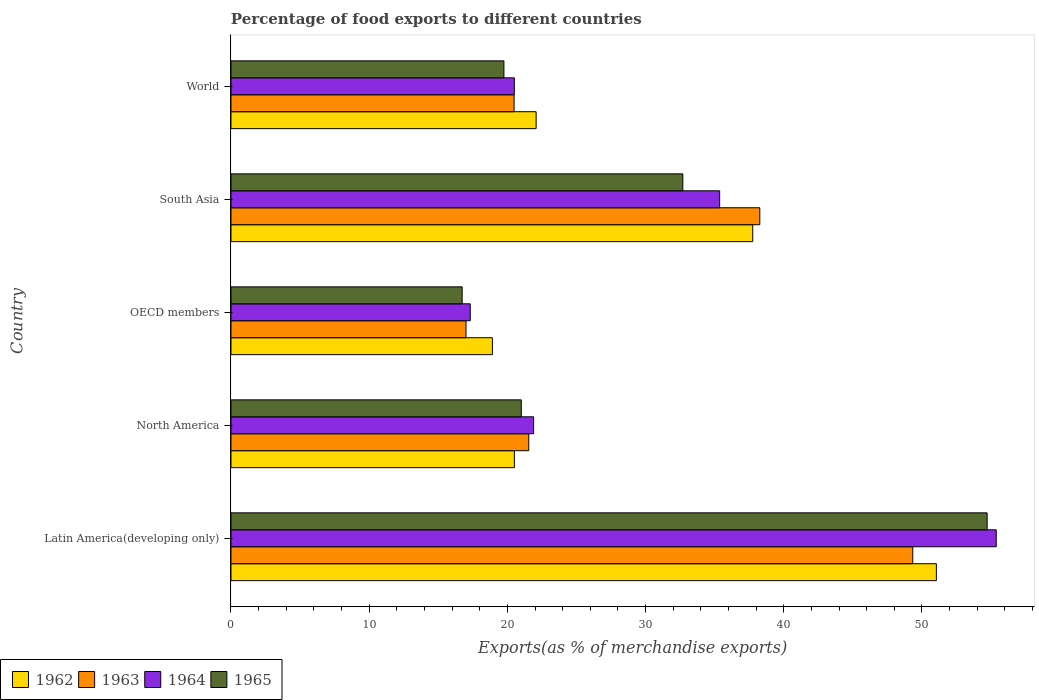How many different coloured bars are there?
Offer a very short reply. 4. How many groups of bars are there?
Make the answer very short. 5. How many bars are there on the 1st tick from the top?
Your answer should be very brief. 4. How many bars are there on the 3rd tick from the bottom?
Your answer should be very brief. 4. What is the label of the 1st group of bars from the top?
Your response must be concise. World. In how many cases, is the number of bars for a given country not equal to the number of legend labels?
Your answer should be very brief. 0. What is the percentage of exports to different countries in 1962 in Latin America(developing only)?
Your answer should be compact. 51.04. Across all countries, what is the maximum percentage of exports to different countries in 1965?
Provide a succinct answer. 54.71. Across all countries, what is the minimum percentage of exports to different countries in 1963?
Offer a terse response. 17.01. In which country was the percentage of exports to different countries in 1965 maximum?
Your answer should be compact. Latin America(developing only). In which country was the percentage of exports to different countries in 1963 minimum?
Give a very brief answer. OECD members. What is the total percentage of exports to different countries in 1965 in the graph?
Offer a very short reply. 144.9. What is the difference between the percentage of exports to different countries in 1965 in South Asia and that in World?
Ensure brevity in your answer.  12.95. What is the difference between the percentage of exports to different countries in 1964 in South Asia and the percentage of exports to different countries in 1965 in OECD members?
Give a very brief answer. 18.63. What is the average percentage of exports to different countries in 1962 per country?
Offer a very short reply. 30.06. What is the difference between the percentage of exports to different countries in 1965 and percentage of exports to different countries in 1964 in Latin America(developing only)?
Keep it short and to the point. -0.66. What is the ratio of the percentage of exports to different countries in 1962 in North America to that in World?
Keep it short and to the point. 0.93. Is the percentage of exports to different countries in 1964 in North America less than that in OECD members?
Ensure brevity in your answer.  No. What is the difference between the highest and the second highest percentage of exports to different countries in 1965?
Your answer should be very brief. 22.02. What is the difference between the highest and the lowest percentage of exports to different countries in 1962?
Provide a succinct answer. 32.12. In how many countries, is the percentage of exports to different countries in 1964 greater than the average percentage of exports to different countries in 1964 taken over all countries?
Offer a very short reply. 2. Is the sum of the percentage of exports to different countries in 1965 in North America and World greater than the maximum percentage of exports to different countries in 1964 across all countries?
Offer a very short reply. No. What does the 1st bar from the top in North America represents?
Offer a very short reply. 1965. Is it the case that in every country, the sum of the percentage of exports to different countries in 1964 and percentage of exports to different countries in 1963 is greater than the percentage of exports to different countries in 1962?
Your answer should be very brief. Yes. How many bars are there?
Provide a succinct answer. 20. Are all the bars in the graph horizontal?
Provide a succinct answer. Yes. What is the difference between two consecutive major ticks on the X-axis?
Your response must be concise. 10. Are the values on the major ticks of X-axis written in scientific E-notation?
Make the answer very short. No. Where does the legend appear in the graph?
Offer a terse response. Bottom left. How are the legend labels stacked?
Keep it short and to the point. Horizontal. What is the title of the graph?
Your answer should be very brief. Percentage of food exports to different countries. What is the label or title of the X-axis?
Give a very brief answer. Exports(as % of merchandise exports). What is the label or title of the Y-axis?
Keep it short and to the point. Country. What is the Exports(as % of merchandise exports) in 1962 in Latin America(developing only)?
Provide a short and direct response. 51.04. What is the Exports(as % of merchandise exports) of 1963 in Latin America(developing only)?
Your answer should be very brief. 49.33. What is the Exports(as % of merchandise exports) of 1964 in Latin America(developing only)?
Ensure brevity in your answer.  55.37. What is the Exports(as % of merchandise exports) of 1965 in Latin America(developing only)?
Your response must be concise. 54.71. What is the Exports(as % of merchandise exports) in 1962 in North America?
Offer a terse response. 20.51. What is the Exports(as % of merchandise exports) in 1963 in North America?
Give a very brief answer. 21.55. What is the Exports(as % of merchandise exports) of 1964 in North America?
Ensure brevity in your answer.  21.9. What is the Exports(as % of merchandise exports) in 1965 in North America?
Give a very brief answer. 21.01. What is the Exports(as % of merchandise exports) of 1962 in OECD members?
Provide a short and direct response. 18.92. What is the Exports(as % of merchandise exports) of 1963 in OECD members?
Your response must be concise. 17.01. What is the Exports(as % of merchandise exports) of 1964 in OECD members?
Your answer should be compact. 17.31. What is the Exports(as % of merchandise exports) in 1965 in OECD members?
Your answer should be very brief. 16.73. What is the Exports(as % of merchandise exports) of 1962 in South Asia?
Offer a very short reply. 37.75. What is the Exports(as % of merchandise exports) of 1963 in South Asia?
Provide a succinct answer. 38.26. What is the Exports(as % of merchandise exports) in 1964 in South Asia?
Your answer should be very brief. 35.36. What is the Exports(as % of merchandise exports) in 1965 in South Asia?
Provide a succinct answer. 32.7. What is the Exports(as % of merchandise exports) of 1962 in World?
Offer a terse response. 22.08. What is the Exports(as % of merchandise exports) in 1963 in World?
Make the answer very short. 20.49. What is the Exports(as % of merchandise exports) in 1964 in World?
Provide a succinct answer. 20.5. What is the Exports(as % of merchandise exports) in 1965 in World?
Your answer should be compact. 19.75. Across all countries, what is the maximum Exports(as % of merchandise exports) of 1962?
Your answer should be very brief. 51.04. Across all countries, what is the maximum Exports(as % of merchandise exports) in 1963?
Provide a short and direct response. 49.33. Across all countries, what is the maximum Exports(as % of merchandise exports) of 1964?
Provide a short and direct response. 55.37. Across all countries, what is the maximum Exports(as % of merchandise exports) in 1965?
Offer a terse response. 54.71. Across all countries, what is the minimum Exports(as % of merchandise exports) in 1962?
Keep it short and to the point. 18.92. Across all countries, what is the minimum Exports(as % of merchandise exports) in 1963?
Offer a terse response. 17.01. Across all countries, what is the minimum Exports(as % of merchandise exports) in 1964?
Give a very brief answer. 17.31. Across all countries, what is the minimum Exports(as % of merchandise exports) in 1965?
Offer a terse response. 16.73. What is the total Exports(as % of merchandise exports) in 1962 in the graph?
Provide a short and direct response. 150.3. What is the total Exports(as % of merchandise exports) in 1963 in the graph?
Offer a very short reply. 146.64. What is the total Exports(as % of merchandise exports) in 1964 in the graph?
Keep it short and to the point. 150.45. What is the total Exports(as % of merchandise exports) in 1965 in the graph?
Your answer should be very brief. 144.9. What is the difference between the Exports(as % of merchandise exports) in 1962 in Latin America(developing only) and that in North America?
Your answer should be very brief. 30.53. What is the difference between the Exports(as % of merchandise exports) of 1963 in Latin America(developing only) and that in North America?
Make the answer very short. 27.79. What is the difference between the Exports(as % of merchandise exports) of 1964 in Latin America(developing only) and that in North America?
Your answer should be compact. 33.48. What is the difference between the Exports(as % of merchandise exports) in 1965 in Latin America(developing only) and that in North America?
Provide a succinct answer. 33.71. What is the difference between the Exports(as % of merchandise exports) in 1962 in Latin America(developing only) and that in OECD members?
Your answer should be compact. 32.12. What is the difference between the Exports(as % of merchandise exports) in 1963 in Latin America(developing only) and that in OECD members?
Offer a terse response. 32.33. What is the difference between the Exports(as % of merchandise exports) in 1964 in Latin America(developing only) and that in OECD members?
Keep it short and to the point. 38.06. What is the difference between the Exports(as % of merchandise exports) in 1965 in Latin America(developing only) and that in OECD members?
Your response must be concise. 37.99. What is the difference between the Exports(as % of merchandise exports) of 1962 in Latin America(developing only) and that in South Asia?
Your answer should be very brief. 13.29. What is the difference between the Exports(as % of merchandise exports) in 1963 in Latin America(developing only) and that in South Asia?
Ensure brevity in your answer.  11.07. What is the difference between the Exports(as % of merchandise exports) in 1964 in Latin America(developing only) and that in South Asia?
Make the answer very short. 20.01. What is the difference between the Exports(as % of merchandise exports) in 1965 in Latin America(developing only) and that in South Asia?
Provide a short and direct response. 22.02. What is the difference between the Exports(as % of merchandise exports) of 1962 in Latin America(developing only) and that in World?
Provide a succinct answer. 28.96. What is the difference between the Exports(as % of merchandise exports) in 1963 in Latin America(developing only) and that in World?
Make the answer very short. 28.85. What is the difference between the Exports(as % of merchandise exports) in 1964 in Latin America(developing only) and that in World?
Keep it short and to the point. 34.87. What is the difference between the Exports(as % of merchandise exports) of 1965 in Latin America(developing only) and that in World?
Your response must be concise. 34.96. What is the difference between the Exports(as % of merchandise exports) of 1962 in North America and that in OECD members?
Provide a short and direct response. 1.59. What is the difference between the Exports(as % of merchandise exports) in 1963 in North America and that in OECD members?
Offer a terse response. 4.54. What is the difference between the Exports(as % of merchandise exports) in 1964 in North America and that in OECD members?
Offer a terse response. 4.58. What is the difference between the Exports(as % of merchandise exports) in 1965 in North America and that in OECD members?
Your answer should be very brief. 4.28. What is the difference between the Exports(as % of merchandise exports) of 1962 in North America and that in South Asia?
Ensure brevity in your answer.  -17.25. What is the difference between the Exports(as % of merchandise exports) in 1963 in North America and that in South Asia?
Provide a short and direct response. -16.72. What is the difference between the Exports(as % of merchandise exports) in 1964 in North America and that in South Asia?
Provide a succinct answer. -13.46. What is the difference between the Exports(as % of merchandise exports) of 1965 in North America and that in South Asia?
Make the answer very short. -11.69. What is the difference between the Exports(as % of merchandise exports) in 1962 in North America and that in World?
Your answer should be compact. -1.57. What is the difference between the Exports(as % of merchandise exports) of 1963 in North America and that in World?
Offer a very short reply. 1.06. What is the difference between the Exports(as % of merchandise exports) in 1964 in North America and that in World?
Ensure brevity in your answer.  1.39. What is the difference between the Exports(as % of merchandise exports) in 1965 in North America and that in World?
Provide a succinct answer. 1.26. What is the difference between the Exports(as % of merchandise exports) of 1962 in OECD members and that in South Asia?
Offer a terse response. -18.84. What is the difference between the Exports(as % of merchandise exports) in 1963 in OECD members and that in South Asia?
Give a very brief answer. -21.26. What is the difference between the Exports(as % of merchandise exports) in 1964 in OECD members and that in South Asia?
Provide a succinct answer. -18.05. What is the difference between the Exports(as % of merchandise exports) of 1965 in OECD members and that in South Asia?
Make the answer very short. -15.97. What is the difference between the Exports(as % of merchandise exports) of 1962 in OECD members and that in World?
Provide a short and direct response. -3.16. What is the difference between the Exports(as % of merchandise exports) of 1963 in OECD members and that in World?
Make the answer very short. -3.48. What is the difference between the Exports(as % of merchandise exports) of 1964 in OECD members and that in World?
Keep it short and to the point. -3.19. What is the difference between the Exports(as % of merchandise exports) of 1965 in OECD members and that in World?
Make the answer very short. -3.02. What is the difference between the Exports(as % of merchandise exports) in 1962 in South Asia and that in World?
Provide a short and direct response. 15.67. What is the difference between the Exports(as % of merchandise exports) in 1963 in South Asia and that in World?
Keep it short and to the point. 17.78. What is the difference between the Exports(as % of merchandise exports) of 1964 in South Asia and that in World?
Provide a short and direct response. 14.86. What is the difference between the Exports(as % of merchandise exports) of 1965 in South Asia and that in World?
Offer a terse response. 12.95. What is the difference between the Exports(as % of merchandise exports) of 1962 in Latin America(developing only) and the Exports(as % of merchandise exports) of 1963 in North America?
Ensure brevity in your answer.  29.49. What is the difference between the Exports(as % of merchandise exports) in 1962 in Latin America(developing only) and the Exports(as % of merchandise exports) in 1964 in North America?
Ensure brevity in your answer.  29.14. What is the difference between the Exports(as % of merchandise exports) of 1962 in Latin America(developing only) and the Exports(as % of merchandise exports) of 1965 in North America?
Offer a terse response. 30.03. What is the difference between the Exports(as % of merchandise exports) in 1963 in Latin America(developing only) and the Exports(as % of merchandise exports) in 1964 in North America?
Offer a terse response. 27.44. What is the difference between the Exports(as % of merchandise exports) in 1963 in Latin America(developing only) and the Exports(as % of merchandise exports) in 1965 in North America?
Your response must be concise. 28.33. What is the difference between the Exports(as % of merchandise exports) of 1964 in Latin America(developing only) and the Exports(as % of merchandise exports) of 1965 in North America?
Give a very brief answer. 34.37. What is the difference between the Exports(as % of merchandise exports) in 1962 in Latin America(developing only) and the Exports(as % of merchandise exports) in 1963 in OECD members?
Provide a succinct answer. 34.04. What is the difference between the Exports(as % of merchandise exports) of 1962 in Latin America(developing only) and the Exports(as % of merchandise exports) of 1964 in OECD members?
Give a very brief answer. 33.73. What is the difference between the Exports(as % of merchandise exports) in 1962 in Latin America(developing only) and the Exports(as % of merchandise exports) in 1965 in OECD members?
Make the answer very short. 34.31. What is the difference between the Exports(as % of merchandise exports) of 1963 in Latin America(developing only) and the Exports(as % of merchandise exports) of 1964 in OECD members?
Offer a very short reply. 32.02. What is the difference between the Exports(as % of merchandise exports) in 1963 in Latin America(developing only) and the Exports(as % of merchandise exports) in 1965 in OECD members?
Provide a short and direct response. 32.61. What is the difference between the Exports(as % of merchandise exports) of 1964 in Latin America(developing only) and the Exports(as % of merchandise exports) of 1965 in OECD members?
Your answer should be compact. 38.64. What is the difference between the Exports(as % of merchandise exports) of 1962 in Latin America(developing only) and the Exports(as % of merchandise exports) of 1963 in South Asia?
Keep it short and to the point. 12.78. What is the difference between the Exports(as % of merchandise exports) in 1962 in Latin America(developing only) and the Exports(as % of merchandise exports) in 1964 in South Asia?
Your answer should be very brief. 15.68. What is the difference between the Exports(as % of merchandise exports) in 1962 in Latin America(developing only) and the Exports(as % of merchandise exports) in 1965 in South Asia?
Keep it short and to the point. 18.35. What is the difference between the Exports(as % of merchandise exports) in 1963 in Latin America(developing only) and the Exports(as % of merchandise exports) in 1964 in South Asia?
Offer a very short reply. 13.97. What is the difference between the Exports(as % of merchandise exports) in 1963 in Latin America(developing only) and the Exports(as % of merchandise exports) in 1965 in South Asia?
Your answer should be very brief. 16.64. What is the difference between the Exports(as % of merchandise exports) in 1964 in Latin America(developing only) and the Exports(as % of merchandise exports) in 1965 in South Asia?
Ensure brevity in your answer.  22.68. What is the difference between the Exports(as % of merchandise exports) in 1962 in Latin America(developing only) and the Exports(as % of merchandise exports) in 1963 in World?
Give a very brief answer. 30.56. What is the difference between the Exports(as % of merchandise exports) in 1962 in Latin America(developing only) and the Exports(as % of merchandise exports) in 1964 in World?
Your answer should be very brief. 30.54. What is the difference between the Exports(as % of merchandise exports) of 1962 in Latin America(developing only) and the Exports(as % of merchandise exports) of 1965 in World?
Ensure brevity in your answer.  31.29. What is the difference between the Exports(as % of merchandise exports) in 1963 in Latin America(developing only) and the Exports(as % of merchandise exports) in 1964 in World?
Provide a succinct answer. 28.83. What is the difference between the Exports(as % of merchandise exports) of 1963 in Latin America(developing only) and the Exports(as % of merchandise exports) of 1965 in World?
Your answer should be very brief. 29.58. What is the difference between the Exports(as % of merchandise exports) of 1964 in Latin America(developing only) and the Exports(as % of merchandise exports) of 1965 in World?
Ensure brevity in your answer.  35.62. What is the difference between the Exports(as % of merchandise exports) of 1962 in North America and the Exports(as % of merchandise exports) of 1963 in OECD members?
Keep it short and to the point. 3.5. What is the difference between the Exports(as % of merchandise exports) of 1962 in North America and the Exports(as % of merchandise exports) of 1964 in OECD members?
Ensure brevity in your answer.  3.19. What is the difference between the Exports(as % of merchandise exports) of 1962 in North America and the Exports(as % of merchandise exports) of 1965 in OECD members?
Your answer should be very brief. 3.78. What is the difference between the Exports(as % of merchandise exports) of 1963 in North America and the Exports(as % of merchandise exports) of 1964 in OECD members?
Give a very brief answer. 4.23. What is the difference between the Exports(as % of merchandise exports) in 1963 in North America and the Exports(as % of merchandise exports) in 1965 in OECD members?
Provide a succinct answer. 4.82. What is the difference between the Exports(as % of merchandise exports) of 1964 in North America and the Exports(as % of merchandise exports) of 1965 in OECD members?
Keep it short and to the point. 5.17. What is the difference between the Exports(as % of merchandise exports) of 1962 in North America and the Exports(as % of merchandise exports) of 1963 in South Asia?
Make the answer very short. -17.76. What is the difference between the Exports(as % of merchandise exports) in 1962 in North America and the Exports(as % of merchandise exports) in 1964 in South Asia?
Give a very brief answer. -14.85. What is the difference between the Exports(as % of merchandise exports) of 1962 in North America and the Exports(as % of merchandise exports) of 1965 in South Asia?
Provide a short and direct response. -12.19. What is the difference between the Exports(as % of merchandise exports) in 1963 in North America and the Exports(as % of merchandise exports) in 1964 in South Asia?
Provide a short and direct response. -13.81. What is the difference between the Exports(as % of merchandise exports) of 1963 in North America and the Exports(as % of merchandise exports) of 1965 in South Asia?
Ensure brevity in your answer.  -11.15. What is the difference between the Exports(as % of merchandise exports) of 1964 in North America and the Exports(as % of merchandise exports) of 1965 in South Asia?
Make the answer very short. -10.8. What is the difference between the Exports(as % of merchandise exports) of 1962 in North America and the Exports(as % of merchandise exports) of 1963 in World?
Keep it short and to the point. 0.02. What is the difference between the Exports(as % of merchandise exports) of 1962 in North America and the Exports(as % of merchandise exports) of 1964 in World?
Ensure brevity in your answer.  0.01. What is the difference between the Exports(as % of merchandise exports) of 1962 in North America and the Exports(as % of merchandise exports) of 1965 in World?
Your response must be concise. 0.76. What is the difference between the Exports(as % of merchandise exports) of 1963 in North America and the Exports(as % of merchandise exports) of 1964 in World?
Make the answer very short. 1.04. What is the difference between the Exports(as % of merchandise exports) in 1963 in North America and the Exports(as % of merchandise exports) in 1965 in World?
Offer a very short reply. 1.8. What is the difference between the Exports(as % of merchandise exports) in 1964 in North America and the Exports(as % of merchandise exports) in 1965 in World?
Your answer should be compact. 2.15. What is the difference between the Exports(as % of merchandise exports) of 1962 in OECD members and the Exports(as % of merchandise exports) of 1963 in South Asia?
Provide a short and direct response. -19.35. What is the difference between the Exports(as % of merchandise exports) of 1962 in OECD members and the Exports(as % of merchandise exports) of 1964 in South Asia?
Provide a short and direct response. -16.44. What is the difference between the Exports(as % of merchandise exports) in 1962 in OECD members and the Exports(as % of merchandise exports) in 1965 in South Asia?
Make the answer very short. -13.78. What is the difference between the Exports(as % of merchandise exports) in 1963 in OECD members and the Exports(as % of merchandise exports) in 1964 in South Asia?
Your answer should be compact. -18.35. What is the difference between the Exports(as % of merchandise exports) of 1963 in OECD members and the Exports(as % of merchandise exports) of 1965 in South Asia?
Provide a succinct answer. -15.69. What is the difference between the Exports(as % of merchandise exports) in 1964 in OECD members and the Exports(as % of merchandise exports) in 1965 in South Asia?
Keep it short and to the point. -15.38. What is the difference between the Exports(as % of merchandise exports) of 1962 in OECD members and the Exports(as % of merchandise exports) of 1963 in World?
Offer a terse response. -1.57. What is the difference between the Exports(as % of merchandise exports) of 1962 in OECD members and the Exports(as % of merchandise exports) of 1964 in World?
Provide a short and direct response. -1.59. What is the difference between the Exports(as % of merchandise exports) in 1962 in OECD members and the Exports(as % of merchandise exports) in 1965 in World?
Keep it short and to the point. -0.83. What is the difference between the Exports(as % of merchandise exports) in 1963 in OECD members and the Exports(as % of merchandise exports) in 1964 in World?
Your response must be concise. -3.5. What is the difference between the Exports(as % of merchandise exports) in 1963 in OECD members and the Exports(as % of merchandise exports) in 1965 in World?
Make the answer very short. -2.74. What is the difference between the Exports(as % of merchandise exports) of 1964 in OECD members and the Exports(as % of merchandise exports) of 1965 in World?
Provide a succinct answer. -2.44. What is the difference between the Exports(as % of merchandise exports) in 1962 in South Asia and the Exports(as % of merchandise exports) in 1963 in World?
Provide a short and direct response. 17.27. What is the difference between the Exports(as % of merchandise exports) in 1962 in South Asia and the Exports(as % of merchandise exports) in 1964 in World?
Your response must be concise. 17.25. What is the difference between the Exports(as % of merchandise exports) in 1962 in South Asia and the Exports(as % of merchandise exports) in 1965 in World?
Offer a terse response. 18. What is the difference between the Exports(as % of merchandise exports) of 1963 in South Asia and the Exports(as % of merchandise exports) of 1964 in World?
Offer a terse response. 17.76. What is the difference between the Exports(as % of merchandise exports) of 1963 in South Asia and the Exports(as % of merchandise exports) of 1965 in World?
Your answer should be very brief. 18.51. What is the difference between the Exports(as % of merchandise exports) in 1964 in South Asia and the Exports(as % of merchandise exports) in 1965 in World?
Your answer should be compact. 15.61. What is the average Exports(as % of merchandise exports) in 1962 per country?
Provide a succinct answer. 30.06. What is the average Exports(as % of merchandise exports) of 1963 per country?
Provide a short and direct response. 29.33. What is the average Exports(as % of merchandise exports) of 1964 per country?
Your response must be concise. 30.09. What is the average Exports(as % of merchandise exports) in 1965 per country?
Your response must be concise. 28.98. What is the difference between the Exports(as % of merchandise exports) of 1962 and Exports(as % of merchandise exports) of 1963 in Latin America(developing only)?
Ensure brevity in your answer.  1.71. What is the difference between the Exports(as % of merchandise exports) of 1962 and Exports(as % of merchandise exports) of 1964 in Latin America(developing only)?
Offer a terse response. -4.33. What is the difference between the Exports(as % of merchandise exports) in 1962 and Exports(as % of merchandise exports) in 1965 in Latin America(developing only)?
Offer a terse response. -3.67. What is the difference between the Exports(as % of merchandise exports) in 1963 and Exports(as % of merchandise exports) in 1964 in Latin America(developing only)?
Your response must be concise. -6.04. What is the difference between the Exports(as % of merchandise exports) in 1963 and Exports(as % of merchandise exports) in 1965 in Latin America(developing only)?
Ensure brevity in your answer.  -5.38. What is the difference between the Exports(as % of merchandise exports) of 1964 and Exports(as % of merchandise exports) of 1965 in Latin America(developing only)?
Offer a terse response. 0.66. What is the difference between the Exports(as % of merchandise exports) in 1962 and Exports(as % of merchandise exports) in 1963 in North America?
Your response must be concise. -1.04. What is the difference between the Exports(as % of merchandise exports) in 1962 and Exports(as % of merchandise exports) in 1964 in North America?
Offer a terse response. -1.39. What is the difference between the Exports(as % of merchandise exports) of 1962 and Exports(as % of merchandise exports) of 1965 in North America?
Keep it short and to the point. -0.5. What is the difference between the Exports(as % of merchandise exports) in 1963 and Exports(as % of merchandise exports) in 1964 in North America?
Keep it short and to the point. -0.35. What is the difference between the Exports(as % of merchandise exports) of 1963 and Exports(as % of merchandise exports) of 1965 in North America?
Your answer should be compact. 0.54. What is the difference between the Exports(as % of merchandise exports) in 1964 and Exports(as % of merchandise exports) in 1965 in North America?
Offer a very short reply. 0.89. What is the difference between the Exports(as % of merchandise exports) in 1962 and Exports(as % of merchandise exports) in 1963 in OECD members?
Offer a very short reply. 1.91. What is the difference between the Exports(as % of merchandise exports) in 1962 and Exports(as % of merchandise exports) in 1964 in OECD members?
Your answer should be compact. 1.6. What is the difference between the Exports(as % of merchandise exports) of 1962 and Exports(as % of merchandise exports) of 1965 in OECD members?
Give a very brief answer. 2.19. What is the difference between the Exports(as % of merchandise exports) in 1963 and Exports(as % of merchandise exports) in 1964 in OECD members?
Your response must be concise. -0.31. What is the difference between the Exports(as % of merchandise exports) in 1963 and Exports(as % of merchandise exports) in 1965 in OECD members?
Ensure brevity in your answer.  0.28. What is the difference between the Exports(as % of merchandise exports) in 1964 and Exports(as % of merchandise exports) in 1965 in OECD members?
Offer a terse response. 0.59. What is the difference between the Exports(as % of merchandise exports) in 1962 and Exports(as % of merchandise exports) in 1963 in South Asia?
Give a very brief answer. -0.51. What is the difference between the Exports(as % of merchandise exports) in 1962 and Exports(as % of merchandise exports) in 1964 in South Asia?
Your answer should be compact. 2.39. What is the difference between the Exports(as % of merchandise exports) in 1962 and Exports(as % of merchandise exports) in 1965 in South Asia?
Make the answer very short. 5.06. What is the difference between the Exports(as % of merchandise exports) of 1963 and Exports(as % of merchandise exports) of 1964 in South Asia?
Make the answer very short. 2.9. What is the difference between the Exports(as % of merchandise exports) of 1963 and Exports(as % of merchandise exports) of 1965 in South Asia?
Offer a very short reply. 5.57. What is the difference between the Exports(as % of merchandise exports) in 1964 and Exports(as % of merchandise exports) in 1965 in South Asia?
Ensure brevity in your answer.  2.66. What is the difference between the Exports(as % of merchandise exports) in 1962 and Exports(as % of merchandise exports) in 1963 in World?
Offer a terse response. 1.59. What is the difference between the Exports(as % of merchandise exports) of 1962 and Exports(as % of merchandise exports) of 1964 in World?
Offer a terse response. 1.58. What is the difference between the Exports(as % of merchandise exports) in 1962 and Exports(as % of merchandise exports) in 1965 in World?
Provide a succinct answer. 2.33. What is the difference between the Exports(as % of merchandise exports) in 1963 and Exports(as % of merchandise exports) in 1964 in World?
Keep it short and to the point. -0.02. What is the difference between the Exports(as % of merchandise exports) of 1963 and Exports(as % of merchandise exports) of 1965 in World?
Offer a terse response. 0.74. What is the difference between the Exports(as % of merchandise exports) of 1964 and Exports(as % of merchandise exports) of 1965 in World?
Ensure brevity in your answer.  0.75. What is the ratio of the Exports(as % of merchandise exports) in 1962 in Latin America(developing only) to that in North America?
Your response must be concise. 2.49. What is the ratio of the Exports(as % of merchandise exports) in 1963 in Latin America(developing only) to that in North America?
Make the answer very short. 2.29. What is the ratio of the Exports(as % of merchandise exports) of 1964 in Latin America(developing only) to that in North America?
Ensure brevity in your answer.  2.53. What is the ratio of the Exports(as % of merchandise exports) in 1965 in Latin America(developing only) to that in North America?
Ensure brevity in your answer.  2.6. What is the ratio of the Exports(as % of merchandise exports) in 1962 in Latin America(developing only) to that in OECD members?
Your answer should be compact. 2.7. What is the ratio of the Exports(as % of merchandise exports) of 1963 in Latin America(developing only) to that in OECD members?
Give a very brief answer. 2.9. What is the ratio of the Exports(as % of merchandise exports) in 1964 in Latin America(developing only) to that in OECD members?
Make the answer very short. 3.2. What is the ratio of the Exports(as % of merchandise exports) of 1965 in Latin America(developing only) to that in OECD members?
Ensure brevity in your answer.  3.27. What is the ratio of the Exports(as % of merchandise exports) of 1962 in Latin America(developing only) to that in South Asia?
Give a very brief answer. 1.35. What is the ratio of the Exports(as % of merchandise exports) of 1963 in Latin America(developing only) to that in South Asia?
Your response must be concise. 1.29. What is the ratio of the Exports(as % of merchandise exports) in 1964 in Latin America(developing only) to that in South Asia?
Provide a succinct answer. 1.57. What is the ratio of the Exports(as % of merchandise exports) in 1965 in Latin America(developing only) to that in South Asia?
Ensure brevity in your answer.  1.67. What is the ratio of the Exports(as % of merchandise exports) in 1962 in Latin America(developing only) to that in World?
Keep it short and to the point. 2.31. What is the ratio of the Exports(as % of merchandise exports) in 1963 in Latin America(developing only) to that in World?
Ensure brevity in your answer.  2.41. What is the ratio of the Exports(as % of merchandise exports) in 1964 in Latin America(developing only) to that in World?
Provide a succinct answer. 2.7. What is the ratio of the Exports(as % of merchandise exports) in 1965 in Latin America(developing only) to that in World?
Ensure brevity in your answer.  2.77. What is the ratio of the Exports(as % of merchandise exports) of 1962 in North America to that in OECD members?
Provide a succinct answer. 1.08. What is the ratio of the Exports(as % of merchandise exports) of 1963 in North America to that in OECD members?
Your answer should be very brief. 1.27. What is the ratio of the Exports(as % of merchandise exports) of 1964 in North America to that in OECD members?
Keep it short and to the point. 1.26. What is the ratio of the Exports(as % of merchandise exports) of 1965 in North America to that in OECD members?
Ensure brevity in your answer.  1.26. What is the ratio of the Exports(as % of merchandise exports) of 1962 in North America to that in South Asia?
Offer a terse response. 0.54. What is the ratio of the Exports(as % of merchandise exports) in 1963 in North America to that in South Asia?
Provide a short and direct response. 0.56. What is the ratio of the Exports(as % of merchandise exports) of 1964 in North America to that in South Asia?
Keep it short and to the point. 0.62. What is the ratio of the Exports(as % of merchandise exports) in 1965 in North America to that in South Asia?
Make the answer very short. 0.64. What is the ratio of the Exports(as % of merchandise exports) of 1962 in North America to that in World?
Offer a terse response. 0.93. What is the ratio of the Exports(as % of merchandise exports) of 1963 in North America to that in World?
Provide a short and direct response. 1.05. What is the ratio of the Exports(as % of merchandise exports) of 1964 in North America to that in World?
Your answer should be compact. 1.07. What is the ratio of the Exports(as % of merchandise exports) in 1965 in North America to that in World?
Your response must be concise. 1.06. What is the ratio of the Exports(as % of merchandise exports) of 1962 in OECD members to that in South Asia?
Give a very brief answer. 0.5. What is the ratio of the Exports(as % of merchandise exports) in 1963 in OECD members to that in South Asia?
Your answer should be very brief. 0.44. What is the ratio of the Exports(as % of merchandise exports) in 1964 in OECD members to that in South Asia?
Ensure brevity in your answer.  0.49. What is the ratio of the Exports(as % of merchandise exports) in 1965 in OECD members to that in South Asia?
Make the answer very short. 0.51. What is the ratio of the Exports(as % of merchandise exports) in 1962 in OECD members to that in World?
Ensure brevity in your answer.  0.86. What is the ratio of the Exports(as % of merchandise exports) of 1963 in OECD members to that in World?
Your response must be concise. 0.83. What is the ratio of the Exports(as % of merchandise exports) in 1964 in OECD members to that in World?
Offer a very short reply. 0.84. What is the ratio of the Exports(as % of merchandise exports) of 1965 in OECD members to that in World?
Provide a succinct answer. 0.85. What is the ratio of the Exports(as % of merchandise exports) in 1962 in South Asia to that in World?
Ensure brevity in your answer.  1.71. What is the ratio of the Exports(as % of merchandise exports) in 1963 in South Asia to that in World?
Your answer should be compact. 1.87. What is the ratio of the Exports(as % of merchandise exports) in 1964 in South Asia to that in World?
Your answer should be very brief. 1.72. What is the ratio of the Exports(as % of merchandise exports) in 1965 in South Asia to that in World?
Offer a terse response. 1.66. What is the difference between the highest and the second highest Exports(as % of merchandise exports) in 1962?
Keep it short and to the point. 13.29. What is the difference between the highest and the second highest Exports(as % of merchandise exports) of 1963?
Provide a short and direct response. 11.07. What is the difference between the highest and the second highest Exports(as % of merchandise exports) in 1964?
Your answer should be very brief. 20.01. What is the difference between the highest and the second highest Exports(as % of merchandise exports) of 1965?
Ensure brevity in your answer.  22.02. What is the difference between the highest and the lowest Exports(as % of merchandise exports) in 1962?
Give a very brief answer. 32.12. What is the difference between the highest and the lowest Exports(as % of merchandise exports) of 1963?
Offer a terse response. 32.33. What is the difference between the highest and the lowest Exports(as % of merchandise exports) in 1964?
Make the answer very short. 38.06. What is the difference between the highest and the lowest Exports(as % of merchandise exports) in 1965?
Your answer should be very brief. 37.99. 